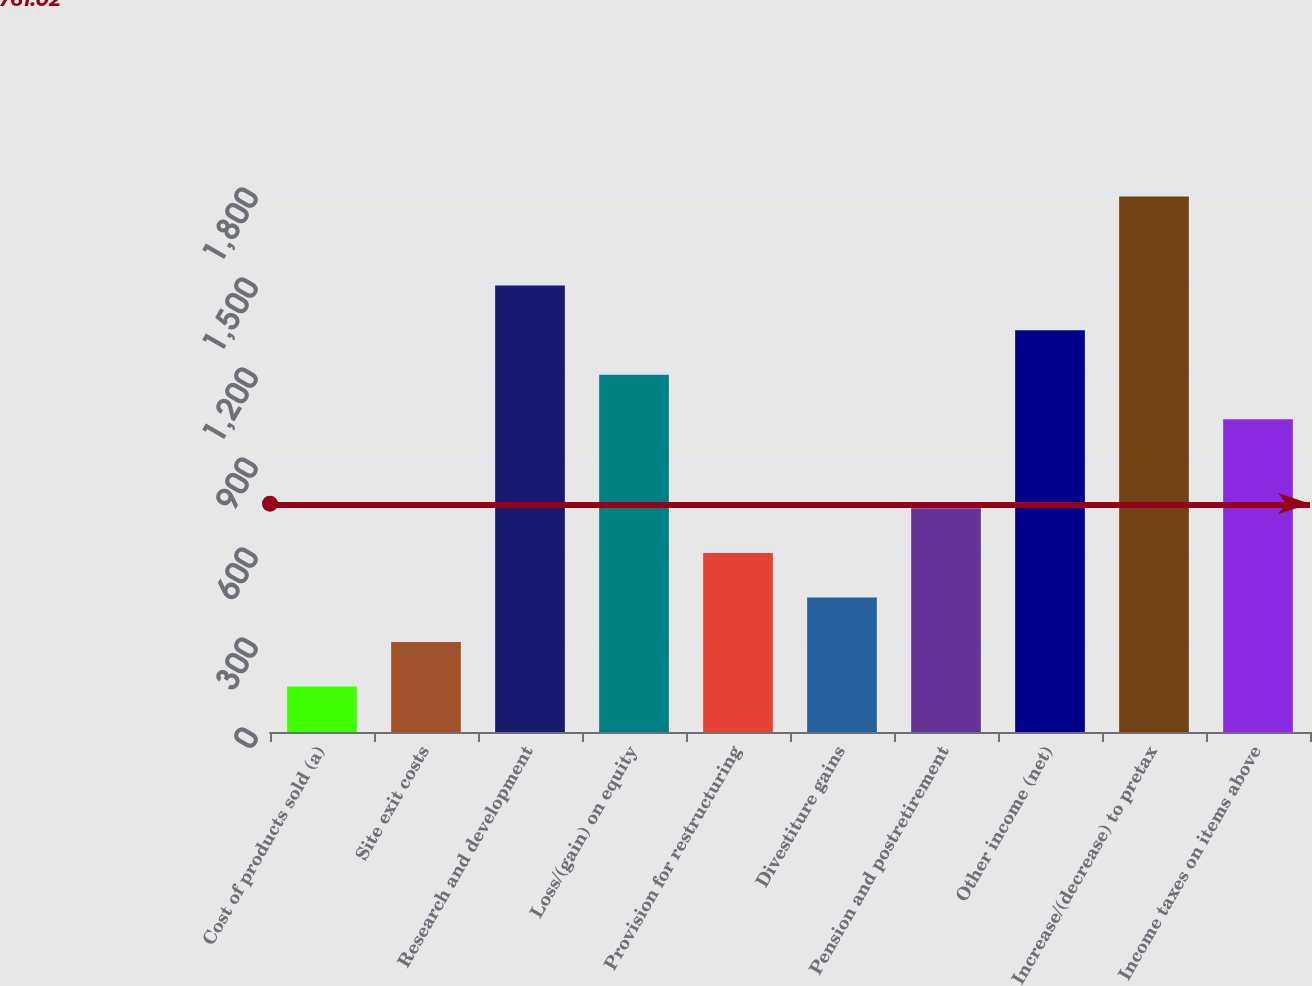Convert chart to OTSL. <chart><loc_0><loc_0><loc_500><loc_500><bar_chart><fcel>Cost of products sold (a)<fcel>Site exit costs<fcel>Research and development<fcel>Loss/(gain) on equity<fcel>Provision for restructuring<fcel>Divestiture gains<fcel>Pension and postretirement<fcel>Other income (net)<fcel>Increase/(decrease) to pretax<fcel>Income taxes on items above<nl><fcel>151.5<fcel>300<fcel>1488<fcel>1191<fcel>597<fcel>448.5<fcel>745.5<fcel>1339.5<fcel>1785<fcel>1042.5<nl></chart> 